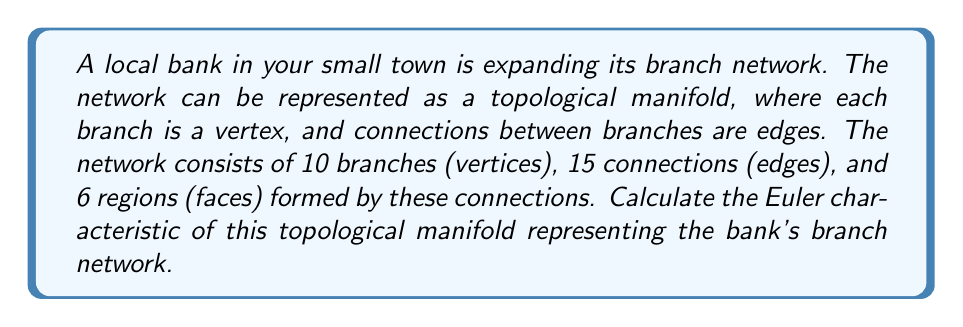Could you help me with this problem? To solve this problem, we'll use the Euler characteristic formula for a topological manifold. The Euler characteristic ($\chi$) is a topological invariant that describes the structure of a topological space regardless of how it is bent or stretched.

For a connected planar graph (which our bank branch network represents), the Euler characteristic is given by the formula:

$$\chi = V - E + F$$

Where:
$V$ = number of vertices (branches)
$E$ = number of edges (connections between branches)
$F$ = number of faces (regions formed by the connections)

Given:
$V = 10$ (branches)
$E = 15$ (connections)
$F = 6$ (regions)

Let's substitute these values into the formula:

$$\chi = 10 - 15 + 6$$

Simplifying:
$$\chi = 1$$

The Euler characteristic of 1 indicates that this topological manifold is equivalent to a sphere. This makes sense for a bank network, as it represents a connected structure without any "holes" in its topology.

It's worth noting that for any simply connected planar graph (like our bank network), the Euler characteristic will always be 2. The fact that we got 1 suggests that we're considering the exterior region as part of our count, which is common in some applications.
Answer: $\chi = 1$ 